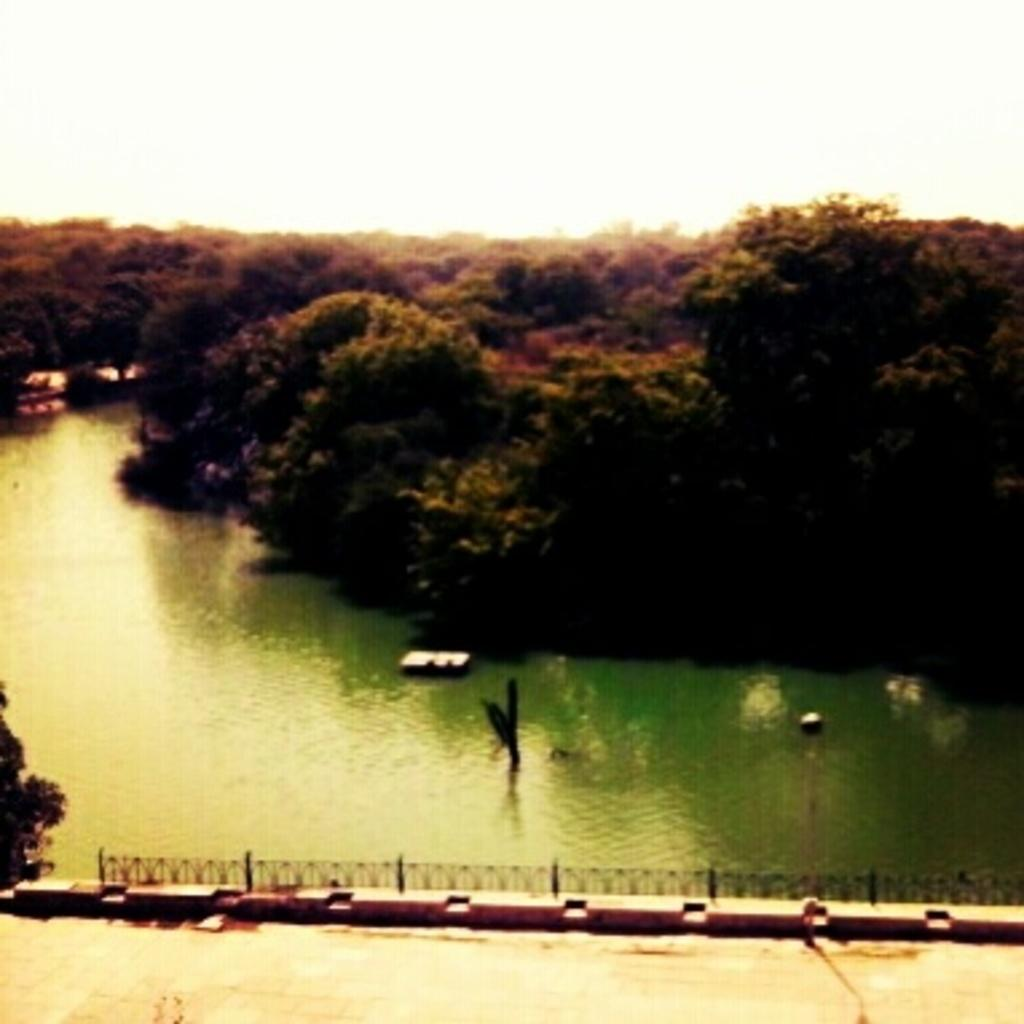What is the main feature of the landscape in the picture? There is a lake in the picture. What can be seen on one side of the lake? There are trees on one side of the lake. What is located on the other side of the lake? There is a road with fencing on the other side of the lake. Where is the aunt sitting at the table in the picture? There is no table or aunt present in the picture; it features a lake with trees and a road with fencing. 